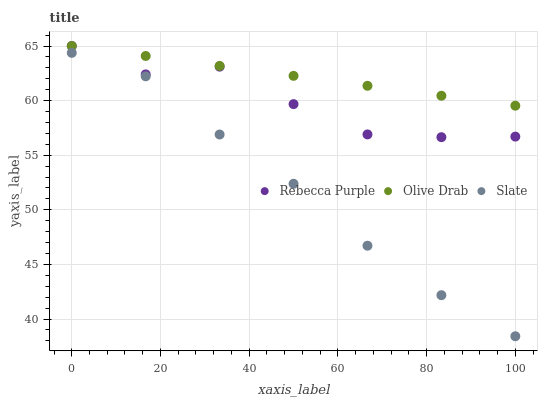Does Slate have the minimum area under the curve?
Answer yes or no. Yes. Does Olive Drab have the maximum area under the curve?
Answer yes or no. Yes. Does Rebecca Purple have the minimum area under the curve?
Answer yes or no. No. Does Rebecca Purple have the maximum area under the curve?
Answer yes or no. No. Is Olive Drab the smoothest?
Answer yes or no. Yes. Is Rebecca Purple the roughest?
Answer yes or no. Yes. Is Rebecca Purple the smoothest?
Answer yes or no. No. Is Olive Drab the roughest?
Answer yes or no. No. Does Slate have the lowest value?
Answer yes or no. Yes. Does Rebecca Purple have the lowest value?
Answer yes or no. No. Does Olive Drab have the highest value?
Answer yes or no. Yes. Is Slate less than Olive Drab?
Answer yes or no. Yes. Is Olive Drab greater than Slate?
Answer yes or no. Yes. Does Rebecca Purple intersect Olive Drab?
Answer yes or no. Yes. Is Rebecca Purple less than Olive Drab?
Answer yes or no. No. Is Rebecca Purple greater than Olive Drab?
Answer yes or no. No. Does Slate intersect Olive Drab?
Answer yes or no. No. 